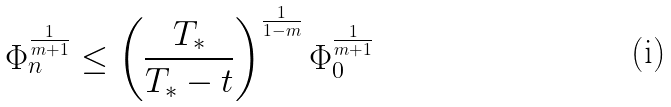Convert formula to latex. <formula><loc_0><loc_0><loc_500><loc_500>\Phi _ { n } ^ { \frac { 1 } { m + 1 } } \leq \left ( { \frac { T _ { * } } { T _ { * } - t } } \right ) ^ { \frac { 1 } { 1 - m } } \Phi _ { 0 } ^ { \frac { 1 } { m + 1 } }</formula> 